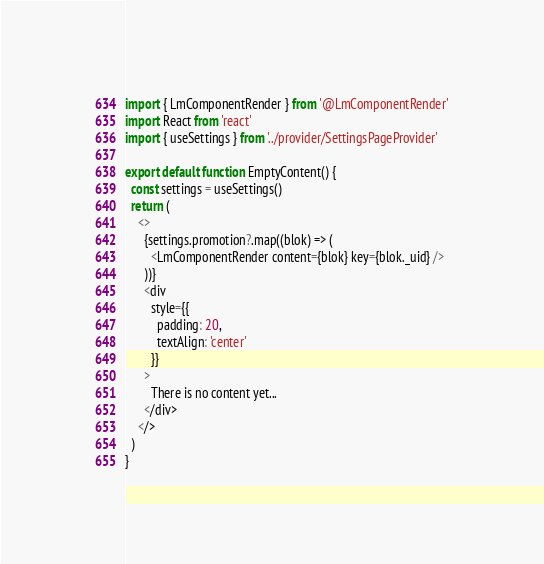<code> <loc_0><loc_0><loc_500><loc_500><_TypeScript_>import { LmComponentRender } from '@LmComponentRender'
import React from 'react'
import { useSettings } from '../provider/SettingsPageProvider'

export default function EmptyContent() {
  const settings = useSettings()
  return (
    <>
      {settings.promotion?.map((blok) => (
        <LmComponentRender content={blok} key={blok._uid} />
      ))}
      <div
        style={{
          padding: 20,
          textAlign: 'center'
        }}
      >
        There is no content yet...
      </div>
    </>
  )
}
</code> 